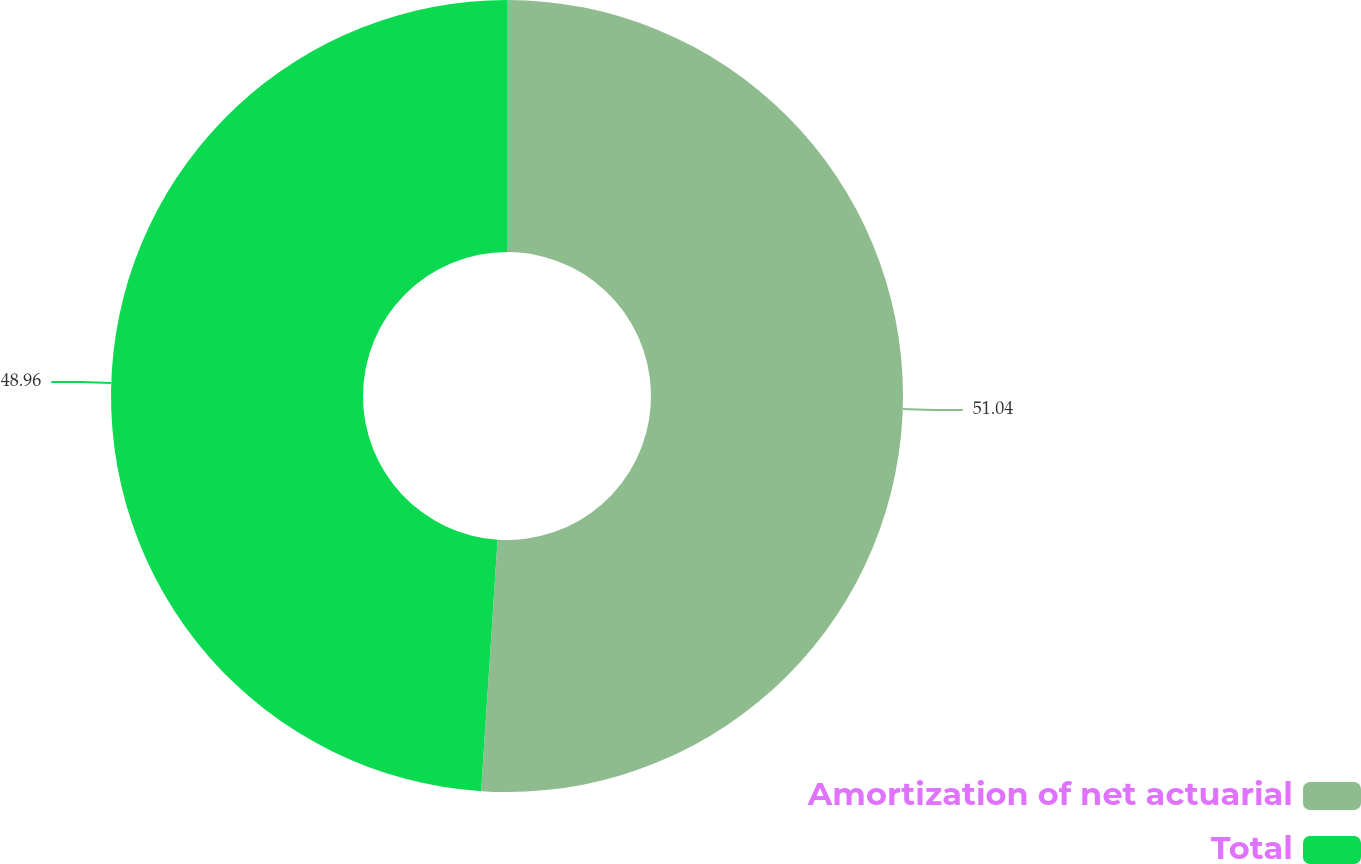Convert chart. <chart><loc_0><loc_0><loc_500><loc_500><pie_chart><fcel>Amortization of net actuarial<fcel>Total<nl><fcel>51.04%<fcel>48.96%<nl></chart> 